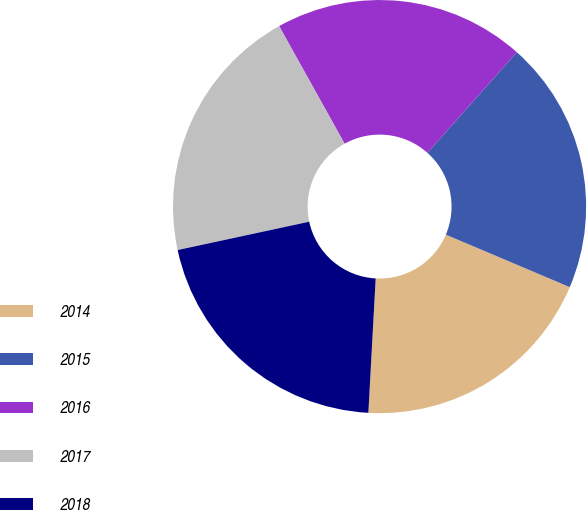Convert chart to OTSL. <chart><loc_0><loc_0><loc_500><loc_500><pie_chart><fcel>2014<fcel>2015<fcel>2016<fcel>2017<fcel>2018<nl><fcel>19.49%<fcel>19.81%<fcel>19.65%<fcel>20.29%<fcel>20.76%<nl></chart> 